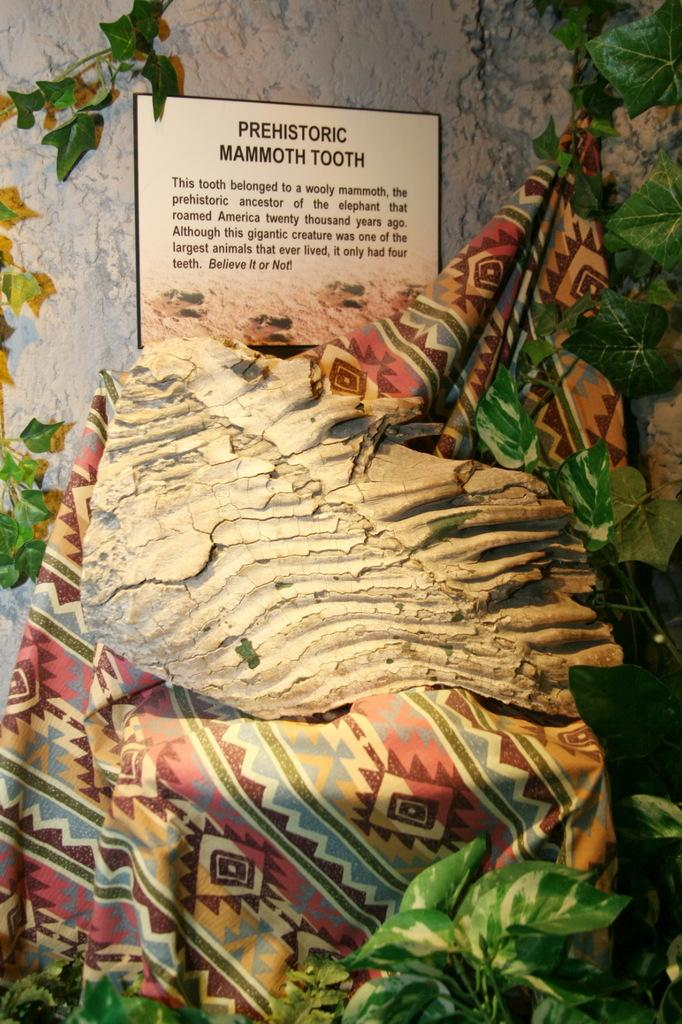<image>
Share a concise interpretation of the image provided. A display at an exhibit that is displaying a large prehistoric mammoth tooth. 